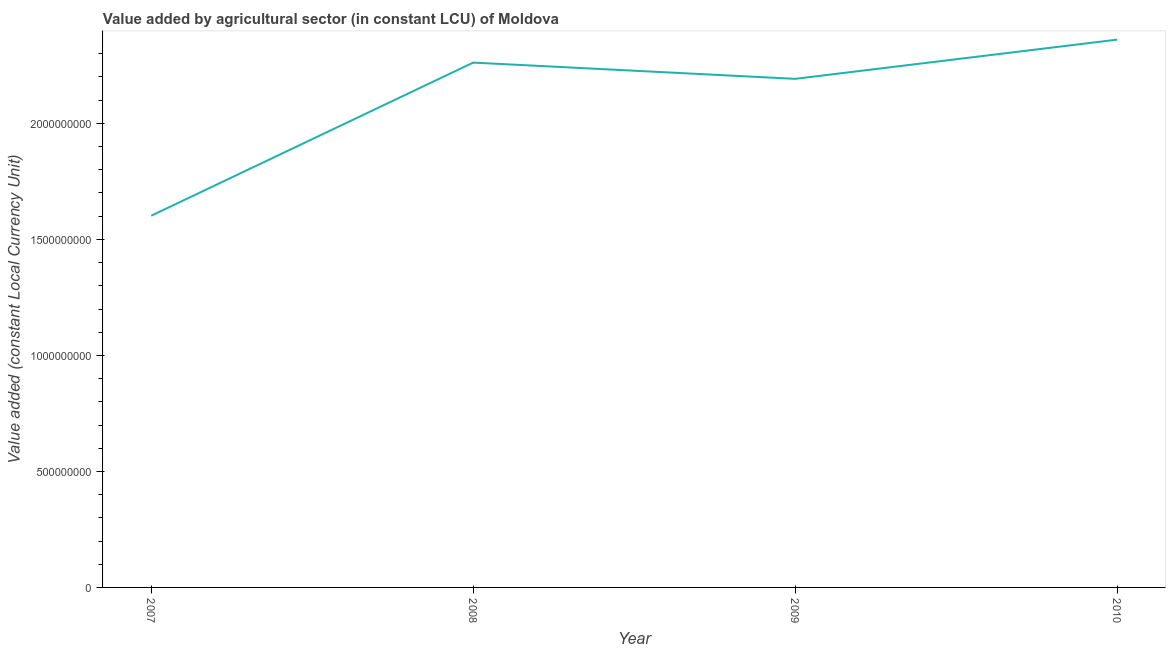What is the value added by agriculture sector in 2009?
Ensure brevity in your answer.  2.19e+09. Across all years, what is the maximum value added by agriculture sector?
Your response must be concise. 2.36e+09. Across all years, what is the minimum value added by agriculture sector?
Make the answer very short. 1.60e+09. In which year was the value added by agriculture sector minimum?
Make the answer very short. 2007. What is the sum of the value added by agriculture sector?
Your answer should be very brief. 8.42e+09. What is the difference between the value added by agriculture sector in 2009 and 2010?
Your response must be concise. -1.69e+08. What is the average value added by agriculture sector per year?
Make the answer very short. 2.10e+09. What is the median value added by agriculture sector?
Your answer should be compact. 2.23e+09. In how many years, is the value added by agriculture sector greater than 100000000 LCU?
Make the answer very short. 4. Do a majority of the years between 2009 and 2010 (inclusive) have value added by agriculture sector greater than 300000000 LCU?
Your response must be concise. Yes. What is the ratio of the value added by agriculture sector in 2007 to that in 2010?
Offer a terse response. 0.68. Is the difference between the value added by agriculture sector in 2008 and 2009 greater than the difference between any two years?
Provide a short and direct response. No. What is the difference between the highest and the second highest value added by agriculture sector?
Your response must be concise. 9.90e+07. What is the difference between the highest and the lowest value added by agriculture sector?
Make the answer very short. 7.59e+08. What is the difference between two consecutive major ticks on the Y-axis?
Ensure brevity in your answer.  5.00e+08. Does the graph contain any zero values?
Your response must be concise. No. Does the graph contain grids?
Your response must be concise. No. What is the title of the graph?
Ensure brevity in your answer.  Value added by agricultural sector (in constant LCU) of Moldova. What is the label or title of the X-axis?
Your answer should be compact. Year. What is the label or title of the Y-axis?
Ensure brevity in your answer.  Value added (constant Local Currency Unit). What is the Value added (constant Local Currency Unit) in 2007?
Offer a terse response. 1.60e+09. What is the Value added (constant Local Currency Unit) of 2008?
Keep it short and to the point. 2.26e+09. What is the Value added (constant Local Currency Unit) in 2009?
Provide a succinct answer. 2.19e+09. What is the Value added (constant Local Currency Unit) in 2010?
Your answer should be very brief. 2.36e+09. What is the difference between the Value added (constant Local Currency Unit) in 2007 and 2008?
Provide a succinct answer. -6.60e+08. What is the difference between the Value added (constant Local Currency Unit) in 2007 and 2009?
Make the answer very short. -5.90e+08. What is the difference between the Value added (constant Local Currency Unit) in 2007 and 2010?
Make the answer very short. -7.59e+08. What is the difference between the Value added (constant Local Currency Unit) in 2008 and 2009?
Ensure brevity in your answer.  7.00e+07. What is the difference between the Value added (constant Local Currency Unit) in 2008 and 2010?
Provide a succinct answer. -9.90e+07. What is the difference between the Value added (constant Local Currency Unit) in 2009 and 2010?
Offer a very short reply. -1.69e+08. What is the ratio of the Value added (constant Local Currency Unit) in 2007 to that in 2008?
Ensure brevity in your answer.  0.71. What is the ratio of the Value added (constant Local Currency Unit) in 2007 to that in 2009?
Offer a terse response. 0.73. What is the ratio of the Value added (constant Local Currency Unit) in 2007 to that in 2010?
Your response must be concise. 0.68. What is the ratio of the Value added (constant Local Currency Unit) in 2008 to that in 2009?
Offer a terse response. 1.03. What is the ratio of the Value added (constant Local Currency Unit) in 2008 to that in 2010?
Your answer should be compact. 0.96. What is the ratio of the Value added (constant Local Currency Unit) in 2009 to that in 2010?
Give a very brief answer. 0.93. 